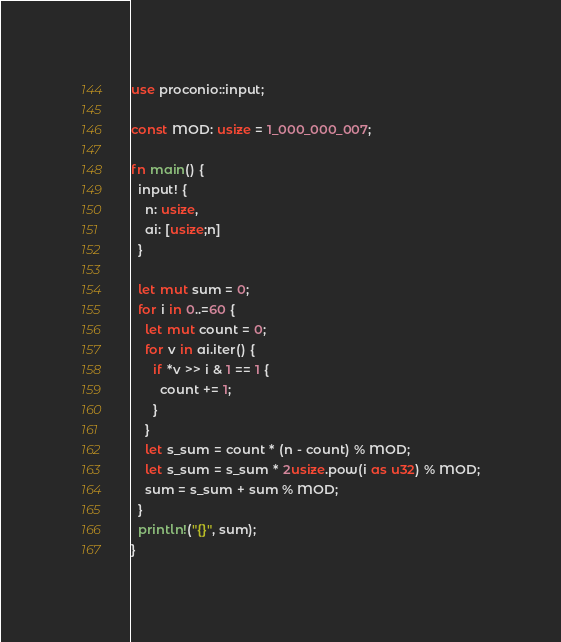<code> <loc_0><loc_0><loc_500><loc_500><_Rust_>use proconio::input;

const MOD: usize = 1_000_000_007;

fn main() {
  input! {
    n: usize,
    ai: [usize;n]
  }
  
  let mut sum = 0;
  for i in 0..=60 {
    let mut count = 0;
    for v in ai.iter() {
      if *v >> i & 1 == 1 {
        count += 1;
      }
    }
    let s_sum = count * (n - count) % MOD;
    let s_sum = s_sum * 2usize.pow(i as u32) % MOD;
    sum = s_sum + sum % MOD;
  }
  println!("{}", sum);
}</code> 